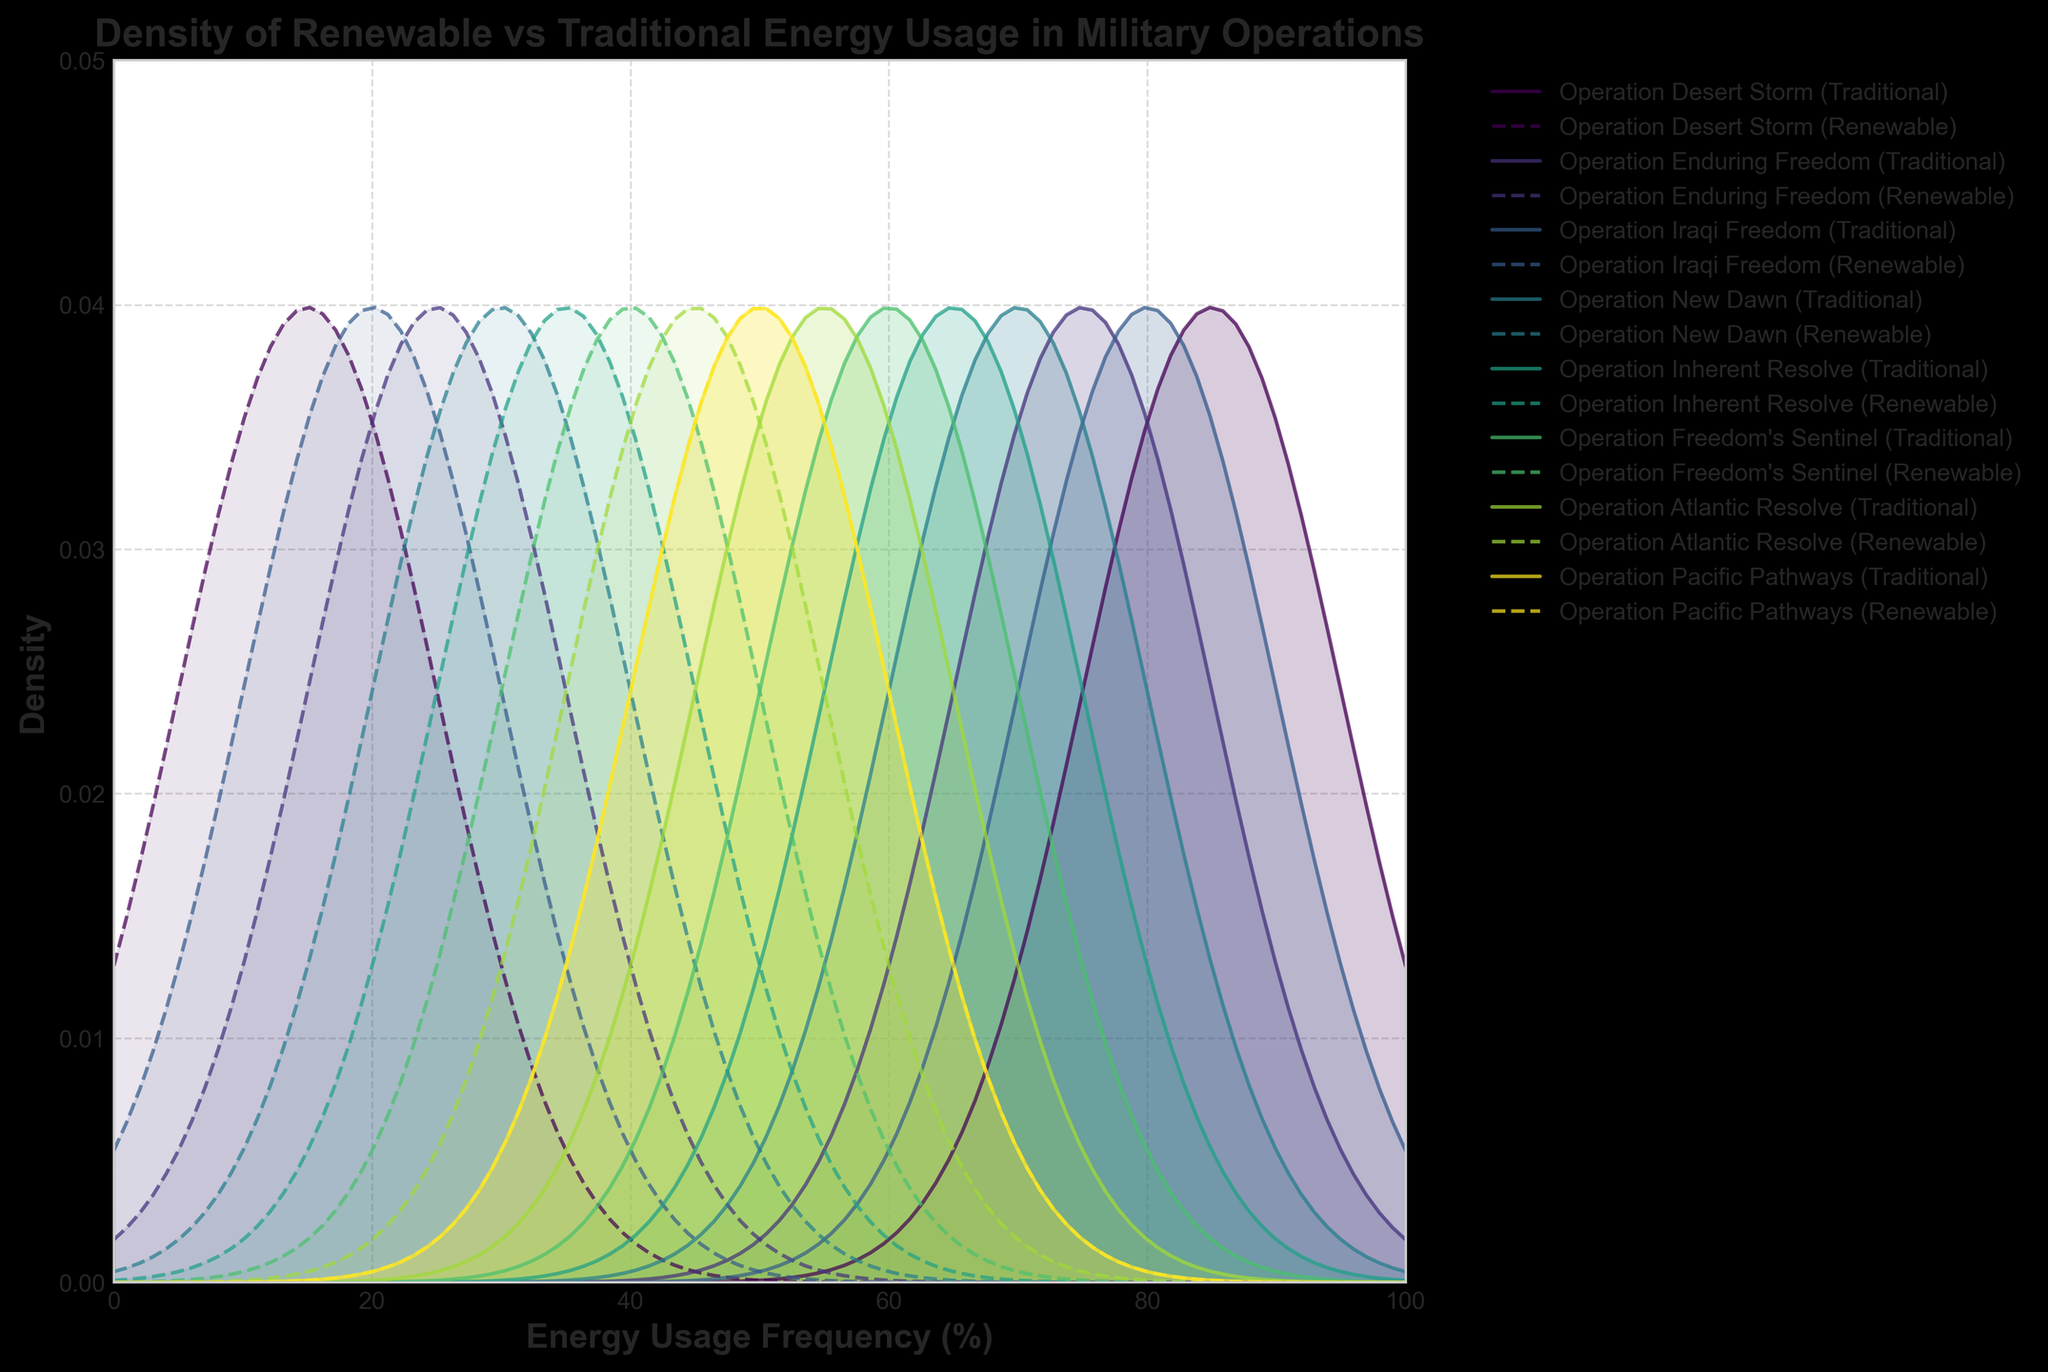How does the density of traditional energy usage compare to renewable energy usage in Operation Inherent Resolve? The plot shows two density curves for Operation Inherent Resolve: a solid line for traditional energy and a dashed line for renewable energy. The density for traditional energy usage peaks higher but at a lower frequency compared to renewable energy usage.
Answer: The density for traditional energy usage peaks higher but at a lower frequency What is the range of the x-axis on the plot? The x-axis represents Energy Usage Frequency (%) and extends from 0 to 100.
Answer: 0 to 100 Which operation has equal traditional and renewable energy usage? By looking at the density plots where traditional and renewable energy curves overlap, Operation Pacific Pathways shows an equal split with both peaking at the same frequency value.
Answer: Operation Pacific Pathways Is there any operation where the peak density for renewable energy usage is higher than for traditional energy usage? For Operation New Dawn and beyond, observe the density curves and their peaks. Operations like Operation Freedom's Sentinel show that the peak density for renewable energy usage is higher than that of traditional energy usage.
Answer: Yes, for Operation Freedom's Sentinel What does the area under each density curve represent? Each area under the density curves represents the probability distribution of energy usage frequencies for traditional and renewable sources in different operations.
Answer: Probability distribution How do traditional energy usage frequencies change across operations? Observe each operation's density curve for traditional energy (solid lines). The frequency peaks shift from around 85% in Operation Desert Storm to 50% in Operation Pacific Pathways. Over time, traditional energy frequencies decrease.
Answer: Decrease over time Which operation has the lowest frequency of traditional energy usage? By examining the peak of each traditional energy density curve, Operation Pacific Pathways shows the lowest frequency at 50%.
Answer: Operation Pacific Pathways What is the highest peak density value for renewable energy usage and in which operation does it occur? Look at the renewable energy usage density curves and identify the highest peak. It occurs for Operation Freedom's Sentinel with the highest peak density value slightly below 0.035.
Answer: Operation Freedom's Sentinel, slightly below 0.035 Which operations exhibit the most balanced energy usage? Check the areas where traditional and renewable density curves are close. Operations like Operation Pacific Pathways and Operation Atlantic Resolve demonstrate the most balanced energy usage, with curves peaking closer to each other.
Answer: Operation Pacific Pathways and Operation Atlantic Resolve How does the density of renewable energy usage change from Operation Desert Storm to Operation Pacific Pathways? Observe the density curves for renewable energy (dashed lines). The peak frequency increases from 15% in Operation Desert Storm to 50% in Operation Pacific Pathways, indicating a rise in renewable energy usage over time.
Answer: Increase over time 